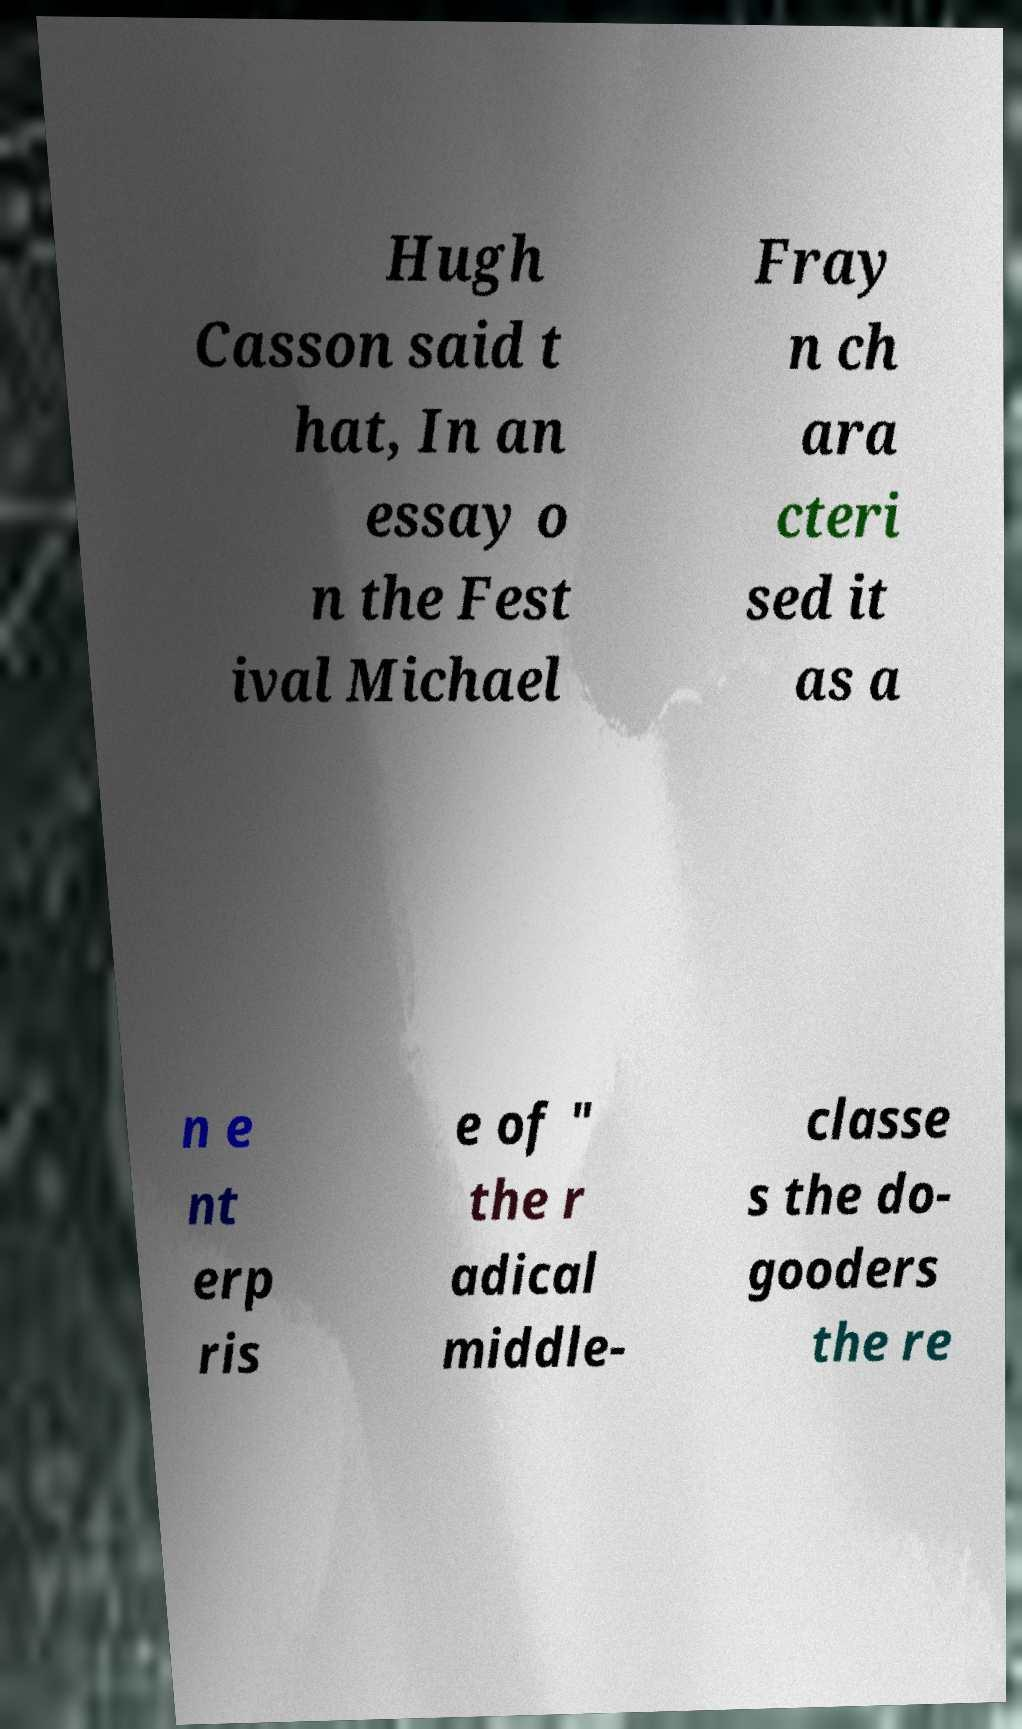Could you assist in decoding the text presented in this image and type it out clearly? Hugh Casson said t hat, In an essay o n the Fest ival Michael Fray n ch ara cteri sed it as a n e nt erp ris e of " the r adical middle- classe s the do- gooders the re 